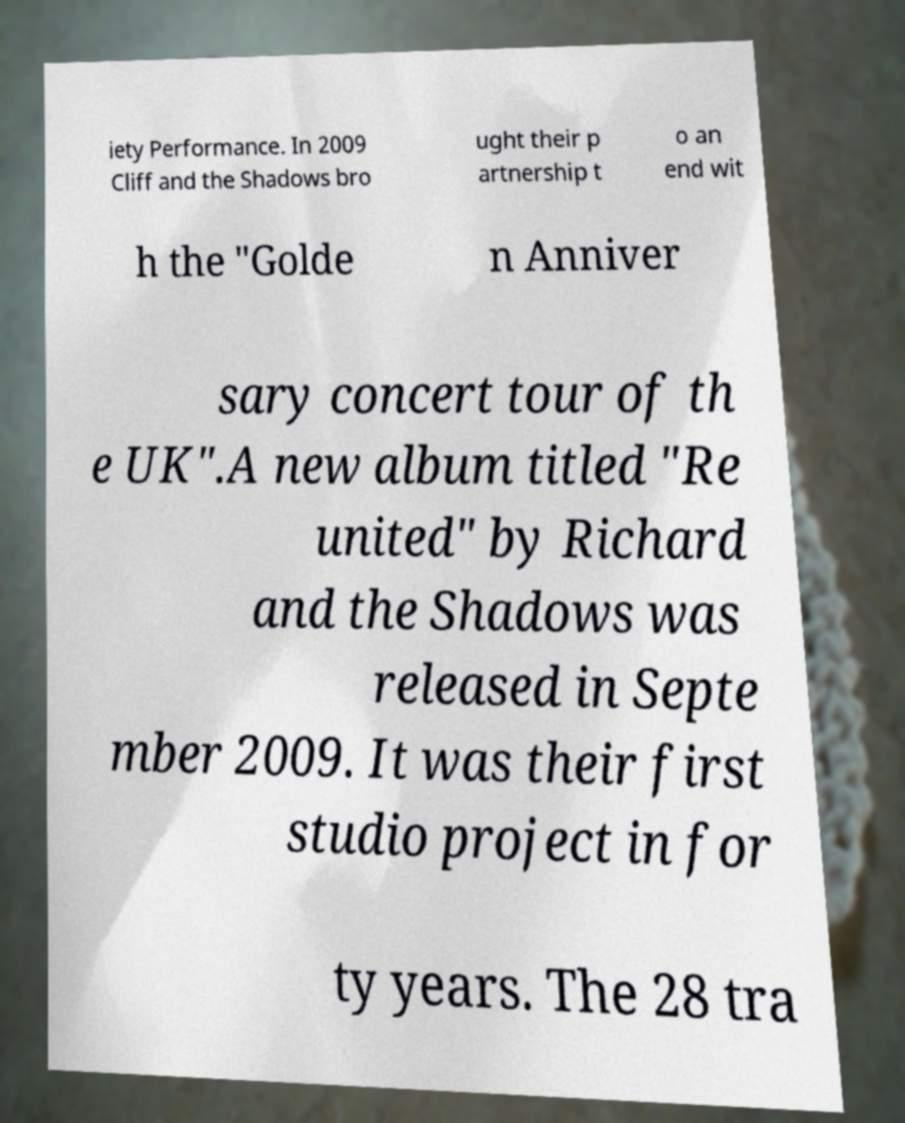Please read and relay the text visible in this image. What does it say? iety Performance. In 2009 Cliff and the Shadows bro ught their p artnership t o an end wit h the "Golde n Anniver sary concert tour of th e UK".A new album titled "Re united" by Richard and the Shadows was released in Septe mber 2009. It was their first studio project in for ty years. The 28 tra 